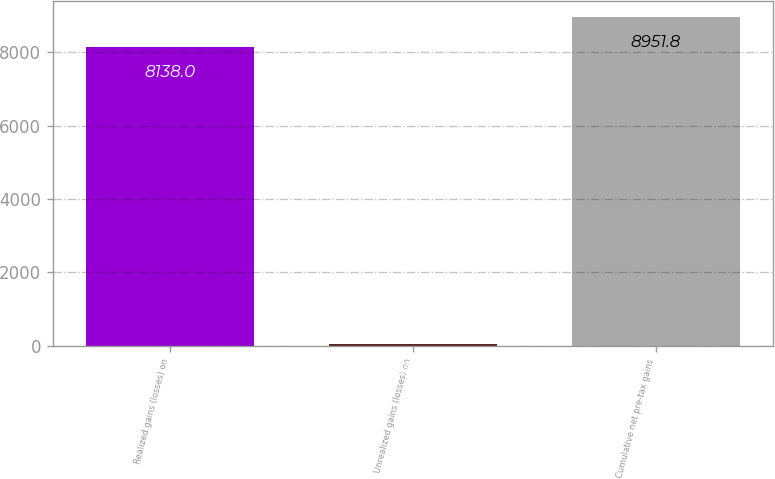<chart> <loc_0><loc_0><loc_500><loc_500><bar_chart><fcel>Realized gains (losses) on<fcel>Unrealized gains (losses) on<fcel>Cumulative net pre-tax gains<nl><fcel>8138<fcel>39<fcel>8951.8<nl></chart> 